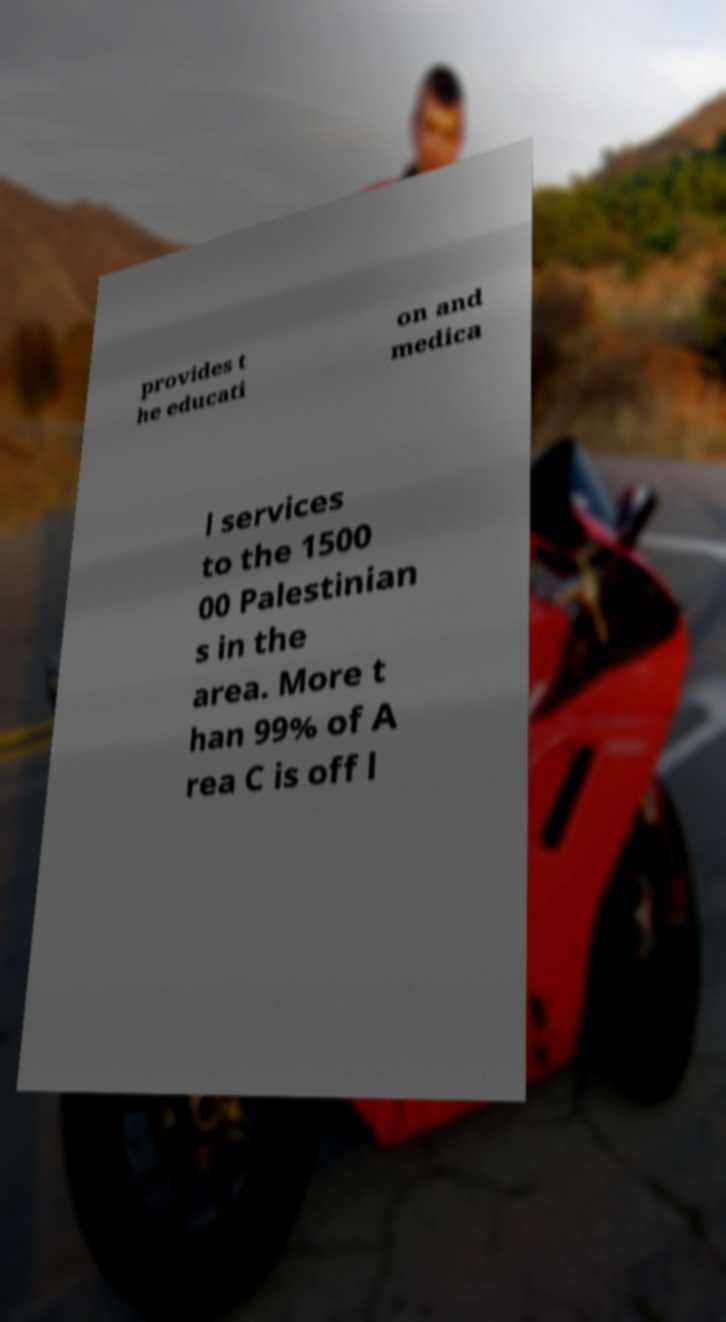For documentation purposes, I need the text within this image transcribed. Could you provide that? provides t he educati on and medica l services to the 1500 00 Palestinian s in the area. More t han 99% of A rea C is off l 